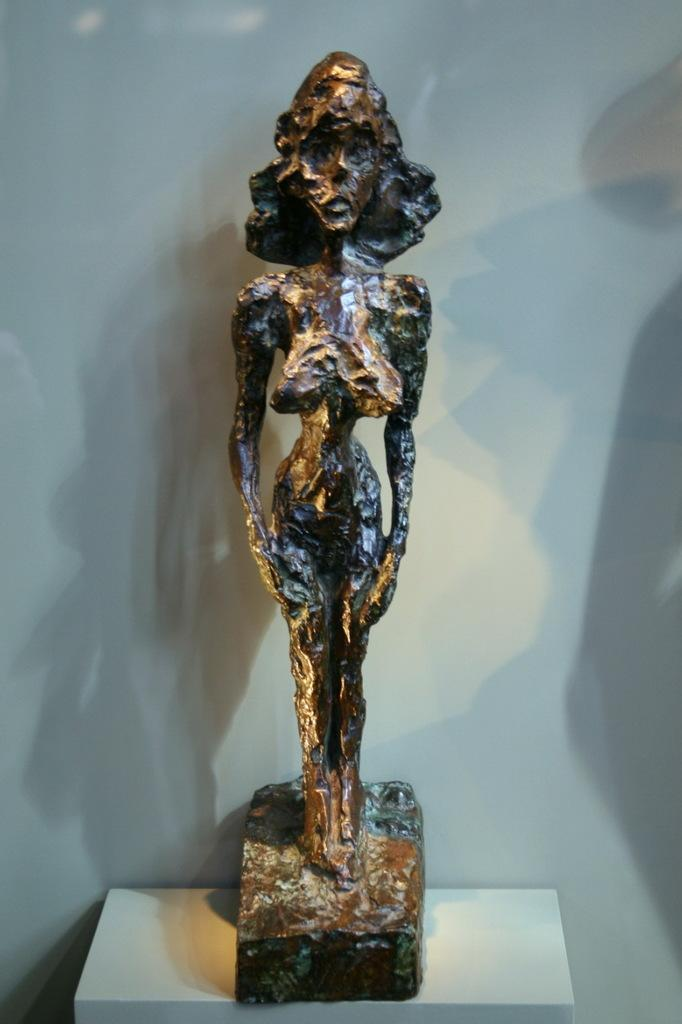What is the main subject in the center of the image? There is a statue in the center of the image. Where is the statue located? The statue is placed on a table. What can be seen in the background of the image? There is a wall in the background of the image. What type of machine is being used to commit a crime in the image? There is no machine or crime present in the image; it features a statue on a table with a wall in the background. 